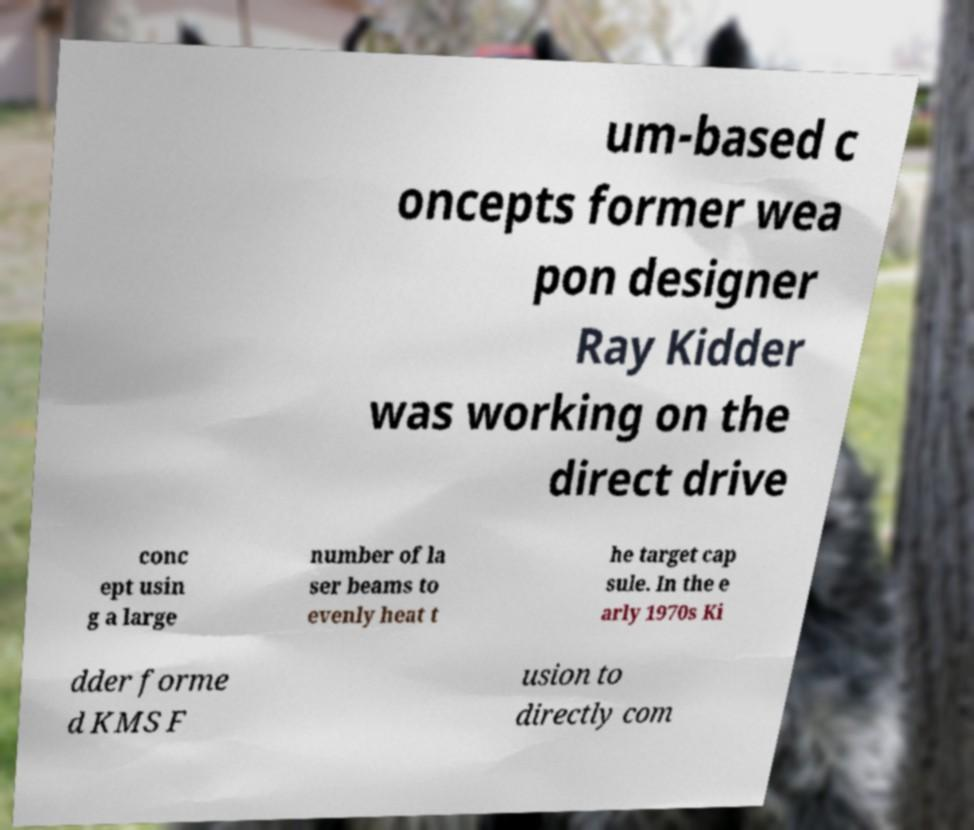Can you accurately transcribe the text from the provided image for me? um-based c oncepts former wea pon designer Ray Kidder was working on the direct drive conc ept usin g a large number of la ser beams to evenly heat t he target cap sule. In the e arly 1970s Ki dder forme d KMS F usion to directly com 